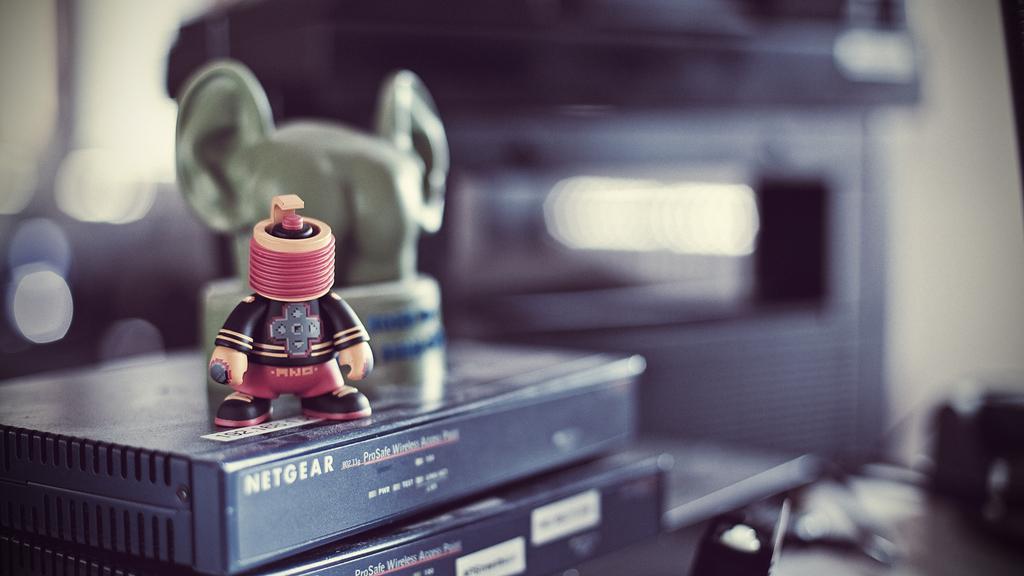Who makes the box the figurine is sitting on?
Provide a short and direct response. Netgear. What kind of access point is the figurine on top of?
Your answer should be compact. Netgear. 